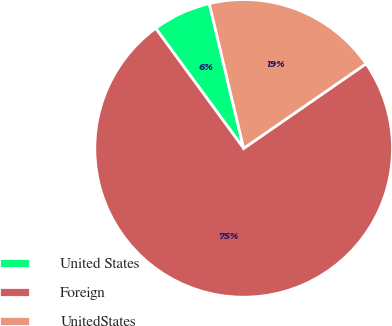Convert chart. <chart><loc_0><loc_0><loc_500><loc_500><pie_chart><fcel>United States<fcel>Foreign<fcel>UnitedStates<nl><fcel>6.36%<fcel>74.56%<fcel>19.08%<nl></chart> 